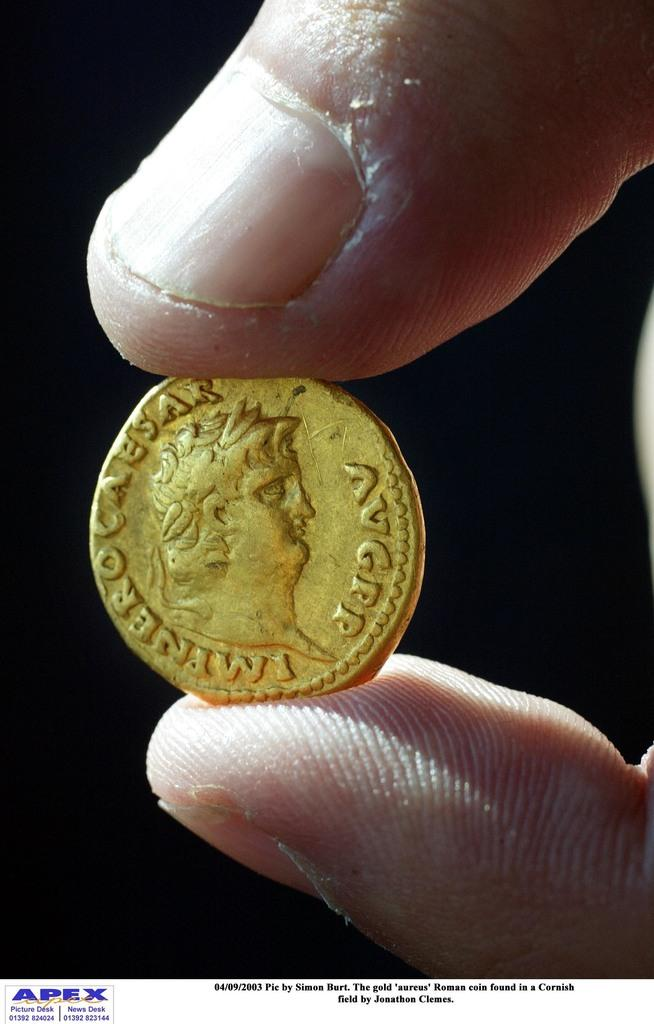<image>
Share a concise interpretation of the image provided. A gold coin with a Caesar written on it. 